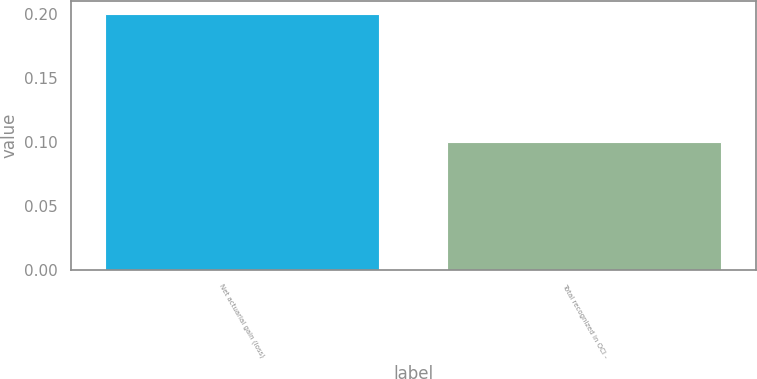Convert chart. <chart><loc_0><loc_0><loc_500><loc_500><bar_chart><fcel>Net actuarial gain (loss)<fcel>Total recognized in OCI -<nl><fcel>0.2<fcel>0.1<nl></chart> 